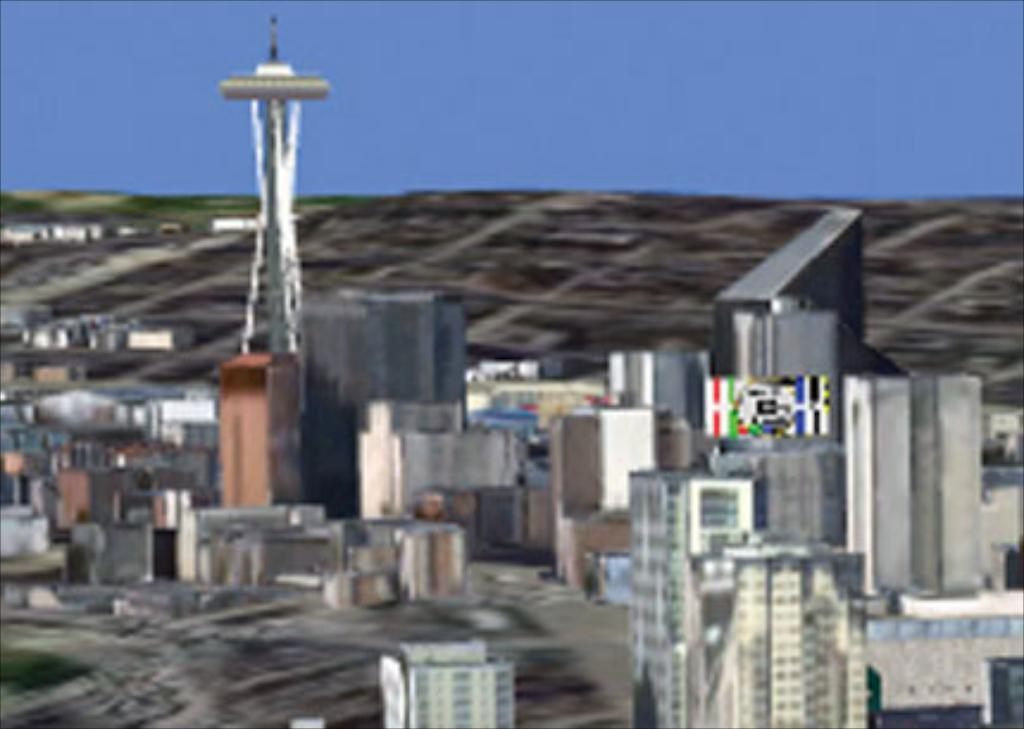What type of image is being described? The image is an animated picture of a city. What specific feature can be seen in the image? There is a tower in the image. What else is present in the image? There are many buildings in the image. What color is the sky in the image? The sky is blue in the image. How many pizzas are being delivered to the buildings in the image? There is no mention of pizzas or deliveries in the image; it is an animated picture of a city with a tower and many buildings. 